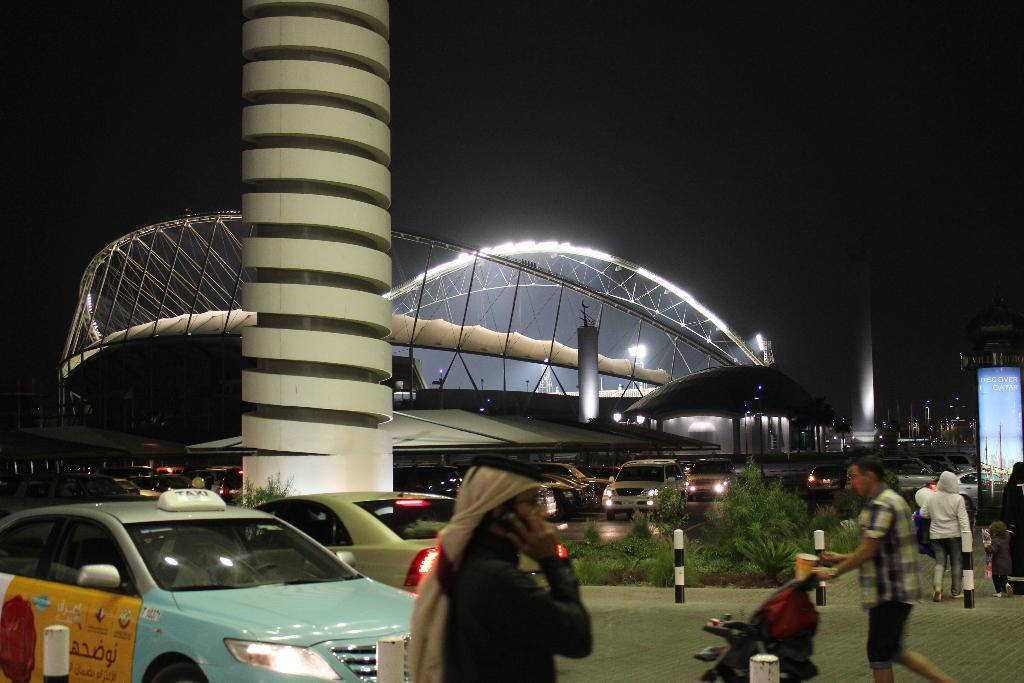What type of structures can be seen in the image? There is architecture in the image. What else can be seen in the image besides the architecture? There are vehicles, pillars, rods, a hoarding, grass, lights, a stroller, a road, and plants visible in the image. Can you describe the background of the image? The sky is visible in the background of the image. What type of apparel is the story wearing in the image? There is no story or apparel present in the image. What mark can be seen on the vehicles in the image? The provided facts do not mention any specific marks on the vehicles, so it cannot be determined from the image. 